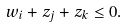<formula> <loc_0><loc_0><loc_500><loc_500>w _ { i } + z _ { j } + z _ { k } \leq 0 .</formula> 